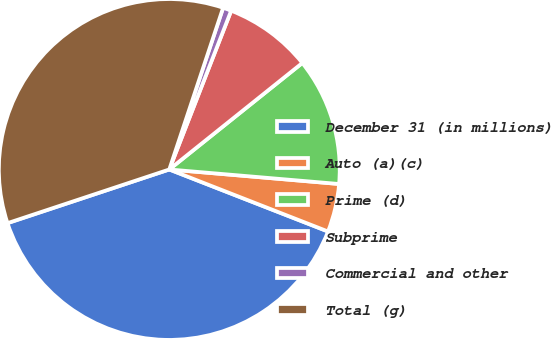<chart> <loc_0><loc_0><loc_500><loc_500><pie_chart><fcel>December 31 (in millions)<fcel>Auto (a)(c)<fcel>Prime (d)<fcel>Subprime<fcel>Commercial and other<fcel>Total (g)<nl><fcel>38.97%<fcel>4.57%<fcel>12.1%<fcel>8.34%<fcel>0.8%<fcel>35.21%<nl></chart> 